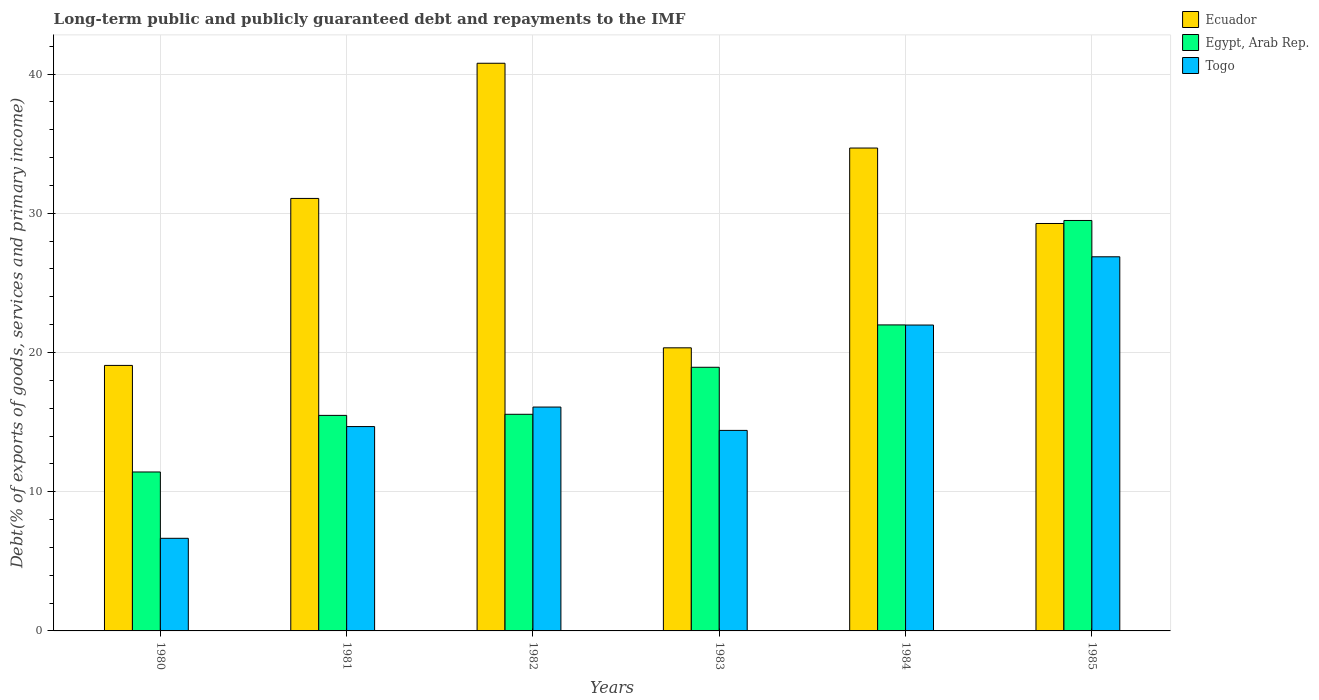Are the number of bars per tick equal to the number of legend labels?
Provide a succinct answer. Yes. Are the number of bars on each tick of the X-axis equal?
Offer a terse response. Yes. How many bars are there on the 6th tick from the left?
Provide a short and direct response. 3. In how many cases, is the number of bars for a given year not equal to the number of legend labels?
Provide a succinct answer. 0. What is the debt and repayments in Ecuador in 1983?
Your answer should be compact. 20.34. Across all years, what is the maximum debt and repayments in Ecuador?
Offer a very short reply. 40.78. Across all years, what is the minimum debt and repayments in Egypt, Arab Rep.?
Keep it short and to the point. 11.42. In which year was the debt and repayments in Ecuador maximum?
Offer a very short reply. 1982. What is the total debt and repayments in Togo in the graph?
Your answer should be very brief. 100.67. What is the difference between the debt and repayments in Egypt, Arab Rep. in 1981 and that in 1982?
Your response must be concise. -0.08. What is the difference between the debt and repayments in Egypt, Arab Rep. in 1983 and the debt and repayments in Ecuador in 1980?
Offer a very short reply. -0.13. What is the average debt and repayments in Togo per year?
Give a very brief answer. 16.78. In the year 1985, what is the difference between the debt and repayments in Egypt, Arab Rep. and debt and repayments in Togo?
Provide a succinct answer. 2.61. In how many years, is the debt and repayments in Ecuador greater than 6 %?
Make the answer very short. 6. What is the ratio of the debt and repayments in Ecuador in 1981 to that in 1982?
Ensure brevity in your answer.  0.76. Is the debt and repayments in Ecuador in 1980 less than that in 1984?
Your answer should be compact. Yes. Is the difference between the debt and repayments in Egypt, Arab Rep. in 1980 and 1984 greater than the difference between the debt and repayments in Togo in 1980 and 1984?
Keep it short and to the point. Yes. What is the difference between the highest and the second highest debt and repayments in Egypt, Arab Rep.?
Ensure brevity in your answer.  7.5. What is the difference between the highest and the lowest debt and repayments in Egypt, Arab Rep.?
Offer a very short reply. 18.07. What does the 1st bar from the left in 1983 represents?
Provide a succinct answer. Ecuador. What does the 1st bar from the right in 1982 represents?
Keep it short and to the point. Togo. Is it the case that in every year, the sum of the debt and repayments in Egypt, Arab Rep. and debt and repayments in Togo is greater than the debt and repayments in Ecuador?
Offer a terse response. No. How many bars are there?
Give a very brief answer. 18. Are all the bars in the graph horizontal?
Keep it short and to the point. No. How many years are there in the graph?
Offer a terse response. 6. Are the values on the major ticks of Y-axis written in scientific E-notation?
Offer a terse response. No. Does the graph contain grids?
Keep it short and to the point. Yes. Where does the legend appear in the graph?
Make the answer very short. Top right. How many legend labels are there?
Your answer should be compact. 3. How are the legend labels stacked?
Offer a terse response. Vertical. What is the title of the graph?
Provide a succinct answer. Long-term public and publicly guaranteed debt and repayments to the IMF. What is the label or title of the X-axis?
Offer a terse response. Years. What is the label or title of the Y-axis?
Your answer should be very brief. Debt(% of exports of goods, services and primary income). What is the Debt(% of exports of goods, services and primary income) of Ecuador in 1980?
Make the answer very short. 19.07. What is the Debt(% of exports of goods, services and primary income) in Egypt, Arab Rep. in 1980?
Your answer should be compact. 11.42. What is the Debt(% of exports of goods, services and primary income) of Togo in 1980?
Give a very brief answer. 6.65. What is the Debt(% of exports of goods, services and primary income) of Ecuador in 1981?
Give a very brief answer. 31.07. What is the Debt(% of exports of goods, services and primary income) of Egypt, Arab Rep. in 1981?
Your answer should be compact. 15.48. What is the Debt(% of exports of goods, services and primary income) of Togo in 1981?
Make the answer very short. 14.68. What is the Debt(% of exports of goods, services and primary income) in Ecuador in 1982?
Offer a terse response. 40.78. What is the Debt(% of exports of goods, services and primary income) in Egypt, Arab Rep. in 1982?
Give a very brief answer. 15.56. What is the Debt(% of exports of goods, services and primary income) of Togo in 1982?
Your response must be concise. 16.08. What is the Debt(% of exports of goods, services and primary income) in Ecuador in 1983?
Your answer should be compact. 20.34. What is the Debt(% of exports of goods, services and primary income) of Egypt, Arab Rep. in 1983?
Your response must be concise. 18.94. What is the Debt(% of exports of goods, services and primary income) in Togo in 1983?
Provide a succinct answer. 14.4. What is the Debt(% of exports of goods, services and primary income) in Ecuador in 1984?
Give a very brief answer. 34.69. What is the Debt(% of exports of goods, services and primary income) of Egypt, Arab Rep. in 1984?
Your response must be concise. 21.98. What is the Debt(% of exports of goods, services and primary income) of Togo in 1984?
Ensure brevity in your answer.  21.97. What is the Debt(% of exports of goods, services and primary income) of Ecuador in 1985?
Your answer should be very brief. 29.27. What is the Debt(% of exports of goods, services and primary income) in Egypt, Arab Rep. in 1985?
Keep it short and to the point. 29.48. What is the Debt(% of exports of goods, services and primary income) of Togo in 1985?
Offer a very short reply. 26.88. Across all years, what is the maximum Debt(% of exports of goods, services and primary income) in Ecuador?
Your response must be concise. 40.78. Across all years, what is the maximum Debt(% of exports of goods, services and primary income) of Egypt, Arab Rep.?
Provide a short and direct response. 29.48. Across all years, what is the maximum Debt(% of exports of goods, services and primary income) of Togo?
Make the answer very short. 26.88. Across all years, what is the minimum Debt(% of exports of goods, services and primary income) in Ecuador?
Your response must be concise. 19.07. Across all years, what is the minimum Debt(% of exports of goods, services and primary income) of Egypt, Arab Rep.?
Give a very brief answer. 11.42. Across all years, what is the minimum Debt(% of exports of goods, services and primary income) in Togo?
Make the answer very short. 6.65. What is the total Debt(% of exports of goods, services and primary income) of Ecuador in the graph?
Your response must be concise. 175.21. What is the total Debt(% of exports of goods, services and primary income) in Egypt, Arab Rep. in the graph?
Your response must be concise. 112.87. What is the total Debt(% of exports of goods, services and primary income) of Togo in the graph?
Keep it short and to the point. 100.67. What is the difference between the Debt(% of exports of goods, services and primary income) of Ecuador in 1980 and that in 1981?
Your answer should be compact. -11.99. What is the difference between the Debt(% of exports of goods, services and primary income) of Egypt, Arab Rep. in 1980 and that in 1981?
Give a very brief answer. -4.07. What is the difference between the Debt(% of exports of goods, services and primary income) of Togo in 1980 and that in 1981?
Keep it short and to the point. -8.03. What is the difference between the Debt(% of exports of goods, services and primary income) in Ecuador in 1980 and that in 1982?
Ensure brevity in your answer.  -21.7. What is the difference between the Debt(% of exports of goods, services and primary income) in Egypt, Arab Rep. in 1980 and that in 1982?
Keep it short and to the point. -4.14. What is the difference between the Debt(% of exports of goods, services and primary income) of Togo in 1980 and that in 1982?
Offer a terse response. -9.43. What is the difference between the Debt(% of exports of goods, services and primary income) in Ecuador in 1980 and that in 1983?
Give a very brief answer. -1.26. What is the difference between the Debt(% of exports of goods, services and primary income) of Egypt, Arab Rep. in 1980 and that in 1983?
Your answer should be very brief. -7.52. What is the difference between the Debt(% of exports of goods, services and primary income) of Togo in 1980 and that in 1983?
Ensure brevity in your answer.  -7.75. What is the difference between the Debt(% of exports of goods, services and primary income) of Ecuador in 1980 and that in 1984?
Ensure brevity in your answer.  -15.61. What is the difference between the Debt(% of exports of goods, services and primary income) of Egypt, Arab Rep. in 1980 and that in 1984?
Your answer should be very brief. -10.56. What is the difference between the Debt(% of exports of goods, services and primary income) in Togo in 1980 and that in 1984?
Your answer should be compact. -15.32. What is the difference between the Debt(% of exports of goods, services and primary income) in Ecuador in 1980 and that in 1985?
Offer a very short reply. -10.19. What is the difference between the Debt(% of exports of goods, services and primary income) of Egypt, Arab Rep. in 1980 and that in 1985?
Offer a terse response. -18.07. What is the difference between the Debt(% of exports of goods, services and primary income) of Togo in 1980 and that in 1985?
Offer a terse response. -20.22. What is the difference between the Debt(% of exports of goods, services and primary income) of Ecuador in 1981 and that in 1982?
Your answer should be compact. -9.71. What is the difference between the Debt(% of exports of goods, services and primary income) of Egypt, Arab Rep. in 1981 and that in 1982?
Make the answer very short. -0.08. What is the difference between the Debt(% of exports of goods, services and primary income) in Togo in 1981 and that in 1982?
Provide a succinct answer. -1.4. What is the difference between the Debt(% of exports of goods, services and primary income) of Ecuador in 1981 and that in 1983?
Give a very brief answer. 10.73. What is the difference between the Debt(% of exports of goods, services and primary income) of Egypt, Arab Rep. in 1981 and that in 1983?
Provide a succinct answer. -3.46. What is the difference between the Debt(% of exports of goods, services and primary income) of Togo in 1981 and that in 1983?
Your response must be concise. 0.28. What is the difference between the Debt(% of exports of goods, services and primary income) in Ecuador in 1981 and that in 1984?
Provide a succinct answer. -3.62. What is the difference between the Debt(% of exports of goods, services and primary income) in Egypt, Arab Rep. in 1981 and that in 1984?
Offer a terse response. -6.5. What is the difference between the Debt(% of exports of goods, services and primary income) in Togo in 1981 and that in 1984?
Offer a terse response. -7.29. What is the difference between the Debt(% of exports of goods, services and primary income) of Ecuador in 1981 and that in 1985?
Your answer should be very brief. 1.8. What is the difference between the Debt(% of exports of goods, services and primary income) in Egypt, Arab Rep. in 1981 and that in 1985?
Keep it short and to the point. -14. What is the difference between the Debt(% of exports of goods, services and primary income) of Togo in 1981 and that in 1985?
Your answer should be very brief. -12.2. What is the difference between the Debt(% of exports of goods, services and primary income) in Ecuador in 1982 and that in 1983?
Your answer should be very brief. 20.44. What is the difference between the Debt(% of exports of goods, services and primary income) in Egypt, Arab Rep. in 1982 and that in 1983?
Offer a very short reply. -3.38. What is the difference between the Debt(% of exports of goods, services and primary income) of Togo in 1982 and that in 1983?
Make the answer very short. 1.68. What is the difference between the Debt(% of exports of goods, services and primary income) in Ecuador in 1982 and that in 1984?
Ensure brevity in your answer.  6.09. What is the difference between the Debt(% of exports of goods, services and primary income) of Egypt, Arab Rep. in 1982 and that in 1984?
Provide a short and direct response. -6.42. What is the difference between the Debt(% of exports of goods, services and primary income) in Togo in 1982 and that in 1984?
Your answer should be very brief. -5.89. What is the difference between the Debt(% of exports of goods, services and primary income) of Ecuador in 1982 and that in 1985?
Offer a terse response. 11.51. What is the difference between the Debt(% of exports of goods, services and primary income) in Egypt, Arab Rep. in 1982 and that in 1985?
Provide a short and direct response. -13.92. What is the difference between the Debt(% of exports of goods, services and primary income) in Togo in 1982 and that in 1985?
Your answer should be compact. -10.79. What is the difference between the Debt(% of exports of goods, services and primary income) in Ecuador in 1983 and that in 1984?
Give a very brief answer. -14.35. What is the difference between the Debt(% of exports of goods, services and primary income) of Egypt, Arab Rep. in 1983 and that in 1984?
Offer a very short reply. -3.04. What is the difference between the Debt(% of exports of goods, services and primary income) in Togo in 1983 and that in 1984?
Your answer should be compact. -7.57. What is the difference between the Debt(% of exports of goods, services and primary income) in Ecuador in 1983 and that in 1985?
Ensure brevity in your answer.  -8.93. What is the difference between the Debt(% of exports of goods, services and primary income) of Egypt, Arab Rep. in 1983 and that in 1985?
Give a very brief answer. -10.54. What is the difference between the Debt(% of exports of goods, services and primary income) of Togo in 1983 and that in 1985?
Make the answer very short. -12.47. What is the difference between the Debt(% of exports of goods, services and primary income) in Ecuador in 1984 and that in 1985?
Make the answer very short. 5.42. What is the difference between the Debt(% of exports of goods, services and primary income) of Egypt, Arab Rep. in 1984 and that in 1985?
Provide a short and direct response. -7.5. What is the difference between the Debt(% of exports of goods, services and primary income) of Togo in 1984 and that in 1985?
Your answer should be compact. -4.9. What is the difference between the Debt(% of exports of goods, services and primary income) of Ecuador in 1980 and the Debt(% of exports of goods, services and primary income) of Egypt, Arab Rep. in 1981?
Provide a succinct answer. 3.59. What is the difference between the Debt(% of exports of goods, services and primary income) in Ecuador in 1980 and the Debt(% of exports of goods, services and primary income) in Togo in 1981?
Your answer should be very brief. 4.39. What is the difference between the Debt(% of exports of goods, services and primary income) of Egypt, Arab Rep. in 1980 and the Debt(% of exports of goods, services and primary income) of Togo in 1981?
Your answer should be very brief. -3.26. What is the difference between the Debt(% of exports of goods, services and primary income) of Ecuador in 1980 and the Debt(% of exports of goods, services and primary income) of Egypt, Arab Rep. in 1982?
Provide a short and direct response. 3.51. What is the difference between the Debt(% of exports of goods, services and primary income) of Ecuador in 1980 and the Debt(% of exports of goods, services and primary income) of Togo in 1982?
Your answer should be very brief. 2.99. What is the difference between the Debt(% of exports of goods, services and primary income) of Egypt, Arab Rep. in 1980 and the Debt(% of exports of goods, services and primary income) of Togo in 1982?
Keep it short and to the point. -4.66. What is the difference between the Debt(% of exports of goods, services and primary income) of Ecuador in 1980 and the Debt(% of exports of goods, services and primary income) of Egypt, Arab Rep. in 1983?
Ensure brevity in your answer.  0.13. What is the difference between the Debt(% of exports of goods, services and primary income) in Ecuador in 1980 and the Debt(% of exports of goods, services and primary income) in Togo in 1983?
Your response must be concise. 4.67. What is the difference between the Debt(% of exports of goods, services and primary income) of Egypt, Arab Rep. in 1980 and the Debt(% of exports of goods, services and primary income) of Togo in 1983?
Provide a short and direct response. -2.99. What is the difference between the Debt(% of exports of goods, services and primary income) in Ecuador in 1980 and the Debt(% of exports of goods, services and primary income) in Egypt, Arab Rep. in 1984?
Ensure brevity in your answer.  -2.91. What is the difference between the Debt(% of exports of goods, services and primary income) in Ecuador in 1980 and the Debt(% of exports of goods, services and primary income) in Togo in 1984?
Offer a terse response. -2.9. What is the difference between the Debt(% of exports of goods, services and primary income) in Egypt, Arab Rep. in 1980 and the Debt(% of exports of goods, services and primary income) in Togo in 1984?
Your response must be concise. -10.56. What is the difference between the Debt(% of exports of goods, services and primary income) of Ecuador in 1980 and the Debt(% of exports of goods, services and primary income) of Egypt, Arab Rep. in 1985?
Provide a succinct answer. -10.41. What is the difference between the Debt(% of exports of goods, services and primary income) in Ecuador in 1980 and the Debt(% of exports of goods, services and primary income) in Togo in 1985?
Provide a short and direct response. -7.8. What is the difference between the Debt(% of exports of goods, services and primary income) of Egypt, Arab Rep. in 1980 and the Debt(% of exports of goods, services and primary income) of Togo in 1985?
Keep it short and to the point. -15.46. What is the difference between the Debt(% of exports of goods, services and primary income) of Ecuador in 1981 and the Debt(% of exports of goods, services and primary income) of Egypt, Arab Rep. in 1982?
Your response must be concise. 15.51. What is the difference between the Debt(% of exports of goods, services and primary income) of Ecuador in 1981 and the Debt(% of exports of goods, services and primary income) of Togo in 1982?
Your response must be concise. 14.99. What is the difference between the Debt(% of exports of goods, services and primary income) of Egypt, Arab Rep. in 1981 and the Debt(% of exports of goods, services and primary income) of Togo in 1982?
Provide a succinct answer. -0.6. What is the difference between the Debt(% of exports of goods, services and primary income) in Ecuador in 1981 and the Debt(% of exports of goods, services and primary income) in Egypt, Arab Rep. in 1983?
Ensure brevity in your answer.  12.13. What is the difference between the Debt(% of exports of goods, services and primary income) in Ecuador in 1981 and the Debt(% of exports of goods, services and primary income) in Togo in 1983?
Offer a terse response. 16.66. What is the difference between the Debt(% of exports of goods, services and primary income) of Egypt, Arab Rep. in 1981 and the Debt(% of exports of goods, services and primary income) of Togo in 1983?
Offer a terse response. 1.08. What is the difference between the Debt(% of exports of goods, services and primary income) of Ecuador in 1981 and the Debt(% of exports of goods, services and primary income) of Egypt, Arab Rep. in 1984?
Offer a very short reply. 9.09. What is the difference between the Debt(% of exports of goods, services and primary income) of Ecuador in 1981 and the Debt(% of exports of goods, services and primary income) of Togo in 1984?
Offer a terse response. 9.09. What is the difference between the Debt(% of exports of goods, services and primary income) in Egypt, Arab Rep. in 1981 and the Debt(% of exports of goods, services and primary income) in Togo in 1984?
Offer a very short reply. -6.49. What is the difference between the Debt(% of exports of goods, services and primary income) of Ecuador in 1981 and the Debt(% of exports of goods, services and primary income) of Egypt, Arab Rep. in 1985?
Offer a very short reply. 1.58. What is the difference between the Debt(% of exports of goods, services and primary income) in Ecuador in 1981 and the Debt(% of exports of goods, services and primary income) in Togo in 1985?
Provide a short and direct response. 4.19. What is the difference between the Debt(% of exports of goods, services and primary income) in Egypt, Arab Rep. in 1981 and the Debt(% of exports of goods, services and primary income) in Togo in 1985?
Offer a terse response. -11.39. What is the difference between the Debt(% of exports of goods, services and primary income) in Ecuador in 1982 and the Debt(% of exports of goods, services and primary income) in Egypt, Arab Rep. in 1983?
Your answer should be compact. 21.84. What is the difference between the Debt(% of exports of goods, services and primary income) in Ecuador in 1982 and the Debt(% of exports of goods, services and primary income) in Togo in 1983?
Give a very brief answer. 26.37. What is the difference between the Debt(% of exports of goods, services and primary income) of Egypt, Arab Rep. in 1982 and the Debt(% of exports of goods, services and primary income) of Togo in 1983?
Make the answer very short. 1.16. What is the difference between the Debt(% of exports of goods, services and primary income) of Ecuador in 1982 and the Debt(% of exports of goods, services and primary income) of Egypt, Arab Rep. in 1984?
Provide a short and direct response. 18.8. What is the difference between the Debt(% of exports of goods, services and primary income) of Ecuador in 1982 and the Debt(% of exports of goods, services and primary income) of Togo in 1984?
Your answer should be very brief. 18.8. What is the difference between the Debt(% of exports of goods, services and primary income) in Egypt, Arab Rep. in 1982 and the Debt(% of exports of goods, services and primary income) in Togo in 1984?
Your answer should be very brief. -6.41. What is the difference between the Debt(% of exports of goods, services and primary income) in Ecuador in 1982 and the Debt(% of exports of goods, services and primary income) in Egypt, Arab Rep. in 1985?
Ensure brevity in your answer.  11.29. What is the difference between the Debt(% of exports of goods, services and primary income) in Ecuador in 1982 and the Debt(% of exports of goods, services and primary income) in Togo in 1985?
Keep it short and to the point. 13.9. What is the difference between the Debt(% of exports of goods, services and primary income) in Egypt, Arab Rep. in 1982 and the Debt(% of exports of goods, services and primary income) in Togo in 1985?
Ensure brevity in your answer.  -11.31. What is the difference between the Debt(% of exports of goods, services and primary income) in Ecuador in 1983 and the Debt(% of exports of goods, services and primary income) in Egypt, Arab Rep. in 1984?
Provide a short and direct response. -1.65. What is the difference between the Debt(% of exports of goods, services and primary income) of Ecuador in 1983 and the Debt(% of exports of goods, services and primary income) of Togo in 1984?
Your answer should be very brief. -1.64. What is the difference between the Debt(% of exports of goods, services and primary income) in Egypt, Arab Rep. in 1983 and the Debt(% of exports of goods, services and primary income) in Togo in 1984?
Give a very brief answer. -3.03. What is the difference between the Debt(% of exports of goods, services and primary income) in Ecuador in 1983 and the Debt(% of exports of goods, services and primary income) in Egypt, Arab Rep. in 1985?
Make the answer very short. -9.15. What is the difference between the Debt(% of exports of goods, services and primary income) in Ecuador in 1983 and the Debt(% of exports of goods, services and primary income) in Togo in 1985?
Offer a terse response. -6.54. What is the difference between the Debt(% of exports of goods, services and primary income) of Egypt, Arab Rep. in 1983 and the Debt(% of exports of goods, services and primary income) of Togo in 1985?
Offer a terse response. -7.94. What is the difference between the Debt(% of exports of goods, services and primary income) in Ecuador in 1984 and the Debt(% of exports of goods, services and primary income) in Egypt, Arab Rep. in 1985?
Your answer should be compact. 5.2. What is the difference between the Debt(% of exports of goods, services and primary income) of Ecuador in 1984 and the Debt(% of exports of goods, services and primary income) of Togo in 1985?
Ensure brevity in your answer.  7.81. What is the difference between the Debt(% of exports of goods, services and primary income) of Egypt, Arab Rep. in 1984 and the Debt(% of exports of goods, services and primary income) of Togo in 1985?
Keep it short and to the point. -4.89. What is the average Debt(% of exports of goods, services and primary income) in Ecuador per year?
Your answer should be very brief. 29.2. What is the average Debt(% of exports of goods, services and primary income) of Egypt, Arab Rep. per year?
Your answer should be compact. 18.81. What is the average Debt(% of exports of goods, services and primary income) in Togo per year?
Offer a very short reply. 16.78. In the year 1980, what is the difference between the Debt(% of exports of goods, services and primary income) in Ecuador and Debt(% of exports of goods, services and primary income) in Egypt, Arab Rep.?
Make the answer very short. 7.66. In the year 1980, what is the difference between the Debt(% of exports of goods, services and primary income) of Ecuador and Debt(% of exports of goods, services and primary income) of Togo?
Your answer should be very brief. 12.42. In the year 1980, what is the difference between the Debt(% of exports of goods, services and primary income) in Egypt, Arab Rep. and Debt(% of exports of goods, services and primary income) in Togo?
Give a very brief answer. 4.77. In the year 1981, what is the difference between the Debt(% of exports of goods, services and primary income) of Ecuador and Debt(% of exports of goods, services and primary income) of Egypt, Arab Rep.?
Provide a succinct answer. 15.58. In the year 1981, what is the difference between the Debt(% of exports of goods, services and primary income) in Ecuador and Debt(% of exports of goods, services and primary income) in Togo?
Ensure brevity in your answer.  16.39. In the year 1981, what is the difference between the Debt(% of exports of goods, services and primary income) in Egypt, Arab Rep. and Debt(% of exports of goods, services and primary income) in Togo?
Your response must be concise. 0.8. In the year 1982, what is the difference between the Debt(% of exports of goods, services and primary income) of Ecuador and Debt(% of exports of goods, services and primary income) of Egypt, Arab Rep.?
Keep it short and to the point. 25.22. In the year 1982, what is the difference between the Debt(% of exports of goods, services and primary income) in Ecuador and Debt(% of exports of goods, services and primary income) in Togo?
Offer a terse response. 24.7. In the year 1982, what is the difference between the Debt(% of exports of goods, services and primary income) of Egypt, Arab Rep. and Debt(% of exports of goods, services and primary income) of Togo?
Your answer should be very brief. -0.52. In the year 1983, what is the difference between the Debt(% of exports of goods, services and primary income) in Ecuador and Debt(% of exports of goods, services and primary income) in Egypt, Arab Rep.?
Offer a very short reply. 1.4. In the year 1983, what is the difference between the Debt(% of exports of goods, services and primary income) of Ecuador and Debt(% of exports of goods, services and primary income) of Togo?
Provide a short and direct response. 5.93. In the year 1983, what is the difference between the Debt(% of exports of goods, services and primary income) in Egypt, Arab Rep. and Debt(% of exports of goods, services and primary income) in Togo?
Your answer should be compact. 4.53. In the year 1984, what is the difference between the Debt(% of exports of goods, services and primary income) in Ecuador and Debt(% of exports of goods, services and primary income) in Egypt, Arab Rep.?
Keep it short and to the point. 12.71. In the year 1984, what is the difference between the Debt(% of exports of goods, services and primary income) in Ecuador and Debt(% of exports of goods, services and primary income) in Togo?
Provide a succinct answer. 12.71. In the year 1984, what is the difference between the Debt(% of exports of goods, services and primary income) of Egypt, Arab Rep. and Debt(% of exports of goods, services and primary income) of Togo?
Your answer should be very brief. 0.01. In the year 1985, what is the difference between the Debt(% of exports of goods, services and primary income) in Ecuador and Debt(% of exports of goods, services and primary income) in Egypt, Arab Rep.?
Offer a terse response. -0.22. In the year 1985, what is the difference between the Debt(% of exports of goods, services and primary income) in Ecuador and Debt(% of exports of goods, services and primary income) in Togo?
Offer a terse response. 2.39. In the year 1985, what is the difference between the Debt(% of exports of goods, services and primary income) of Egypt, Arab Rep. and Debt(% of exports of goods, services and primary income) of Togo?
Your answer should be very brief. 2.61. What is the ratio of the Debt(% of exports of goods, services and primary income) of Ecuador in 1980 to that in 1981?
Provide a short and direct response. 0.61. What is the ratio of the Debt(% of exports of goods, services and primary income) of Egypt, Arab Rep. in 1980 to that in 1981?
Make the answer very short. 0.74. What is the ratio of the Debt(% of exports of goods, services and primary income) in Togo in 1980 to that in 1981?
Your answer should be very brief. 0.45. What is the ratio of the Debt(% of exports of goods, services and primary income) in Ecuador in 1980 to that in 1982?
Make the answer very short. 0.47. What is the ratio of the Debt(% of exports of goods, services and primary income) in Egypt, Arab Rep. in 1980 to that in 1982?
Your response must be concise. 0.73. What is the ratio of the Debt(% of exports of goods, services and primary income) of Togo in 1980 to that in 1982?
Provide a succinct answer. 0.41. What is the ratio of the Debt(% of exports of goods, services and primary income) in Ecuador in 1980 to that in 1983?
Make the answer very short. 0.94. What is the ratio of the Debt(% of exports of goods, services and primary income) in Egypt, Arab Rep. in 1980 to that in 1983?
Provide a short and direct response. 0.6. What is the ratio of the Debt(% of exports of goods, services and primary income) of Togo in 1980 to that in 1983?
Offer a terse response. 0.46. What is the ratio of the Debt(% of exports of goods, services and primary income) in Ecuador in 1980 to that in 1984?
Offer a very short reply. 0.55. What is the ratio of the Debt(% of exports of goods, services and primary income) in Egypt, Arab Rep. in 1980 to that in 1984?
Provide a short and direct response. 0.52. What is the ratio of the Debt(% of exports of goods, services and primary income) of Togo in 1980 to that in 1984?
Provide a short and direct response. 0.3. What is the ratio of the Debt(% of exports of goods, services and primary income) of Ecuador in 1980 to that in 1985?
Provide a succinct answer. 0.65. What is the ratio of the Debt(% of exports of goods, services and primary income) in Egypt, Arab Rep. in 1980 to that in 1985?
Provide a short and direct response. 0.39. What is the ratio of the Debt(% of exports of goods, services and primary income) of Togo in 1980 to that in 1985?
Ensure brevity in your answer.  0.25. What is the ratio of the Debt(% of exports of goods, services and primary income) of Ecuador in 1981 to that in 1982?
Ensure brevity in your answer.  0.76. What is the ratio of the Debt(% of exports of goods, services and primary income) in Egypt, Arab Rep. in 1981 to that in 1982?
Your response must be concise. 0.99. What is the ratio of the Debt(% of exports of goods, services and primary income) of Togo in 1981 to that in 1982?
Make the answer very short. 0.91. What is the ratio of the Debt(% of exports of goods, services and primary income) in Ecuador in 1981 to that in 1983?
Provide a succinct answer. 1.53. What is the ratio of the Debt(% of exports of goods, services and primary income) in Egypt, Arab Rep. in 1981 to that in 1983?
Provide a succinct answer. 0.82. What is the ratio of the Debt(% of exports of goods, services and primary income) of Togo in 1981 to that in 1983?
Make the answer very short. 1.02. What is the ratio of the Debt(% of exports of goods, services and primary income) of Ecuador in 1981 to that in 1984?
Offer a terse response. 0.9. What is the ratio of the Debt(% of exports of goods, services and primary income) in Egypt, Arab Rep. in 1981 to that in 1984?
Ensure brevity in your answer.  0.7. What is the ratio of the Debt(% of exports of goods, services and primary income) in Togo in 1981 to that in 1984?
Your answer should be very brief. 0.67. What is the ratio of the Debt(% of exports of goods, services and primary income) in Ecuador in 1981 to that in 1985?
Make the answer very short. 1.06. What is the ratio of the Debt(% of exports of goods, services and primary income) of Egypt, Arab Rep. in 1981 to that in 1985?
Offer a terse response. 0.53. What is the ratio of the Debt(% of exports of goods, services and primary income) of Togo in 1981 to that in 1985?
Offer a terse response. 0.55. What is the ratio of the Debt(% of exports of goods, services and primary income) in Ecuador in 1982 to that in 1983?
Your response must be concise. 2.01. What is the ratio of the Debt(% of exports of goods, services and primary income) in Egypt, Arab Rep. in 1982 to that in 1983?
Offer a terse response. 0.82. What is the ratio of the Debt(% of exports of goods, services and primary income) of Togo in 1982 to that in 1983?
Offer a terse response. 1.12. What is the ratio of the Debt(% of exports of goods, services and primary income) in Ecuador in 1982 to that in 1984?
Provide a succinct answer. 1.18. What is the ratio of the Debt(% of exports of goods, services and primary income) of Egypt, Arab Rep. in 1982 to that in 1984?
Give a very brief answer. 0.71. What is the ratio of the Debt(% of exports of goods, services and primary income) of Togo in 1982 to that in 1984?
Keep it short and to the point. 0.73. What is the ratio of the Debt(% of exports of goods, services and primary income) of Ecuador in 1982 to that in 1985?
Give a very brief answer. 1.39. What is the ratio of the Debt(% of exports of goods, services and primary income) in Egypt, Arab Rep. in 1982 to that in 1985?
Provide a short and direct response. 0.53. What is the ratio of the Debt(% of exports of goods, services and primary income) in Togo in 1982 to that in 1985?
Provide a short and direct response. 0.6. What is the ratio of the Debt(% of exports of goods, services and primary income) of Ecuador in 1983 to that in 1984?
Offer a very short reply. 0.59. What is the ratio of the Debt(% of exports of goods, services and primary income) of Egypt, Arab Rep. in 1983 to that in 1984?
Make the answer very short. 0.86. What is the ratio of the Debt(% of exports of goods, services and primary income) of Togo in 1983 to that in 1984?
Your answer should be very brief. 0.66. What is the ratio of the Debt(% of exports of goods, services and primary income) of Ecuador in 1983 to that in 1985?
Give a very brief answer. 0.69. What is the ratio of the Debt(% of exports of goods, services and primary income) in Egypt, Arab Rep. in 1983 to that in 1985?
Your answer should be very brief. 0.64. What is the ratio of the Debt(% of exports of goods, services and primary income) in Togo in 1983 to that in 1985?
Your response must be concise. 0.54. What is the ratio of the Debt(% of exports of goods, services and primary income) in Ecuador in 1984 to that in 1985?
Ensure brevity in your answer.  1.19. What is the ratio of the Debt(% of exports of goods, services and primary income) of Egypt, Arab Rep. in 1984 to that in 1985?
Make the answer very short. 0.75. What is the ratio of the Debt(% of exports of goods, services and primary income) in Togo in 1984 to that in 1985?
Provide a succinct answer. 0.82. What is the difference between the highest and the second highest Debt(% of exports of goods, services and primary income) of Ecuador?
Give a very brief answer. 6.09. What is the difference between the highest and the second highest Debt(% of exports of goods, services and primary income) of Egypt, Arab Rep.?
Keep it short and to the point. 7.5. What is the difference between the highest and the second highest Debt(% of exports of goods, services and primary income) of Togo?
Ensure brevity in your answer.  4.9. What is the difference between the highest and the lowest Debt(% of exports of goods, services and primary income) in Ecuador?
Your answer should be compact. 21.7. What is the difference between the highest and the lowest Debt(% of exports of goods, services and primary income) in Egypt, Arab Rep.?
Your answer should be very brief. 18.07. What is the difference between the highest and the lowest Debt(% of exports of goods, services and primary income) in Togo?
Offer a very short reply. 20.22. 